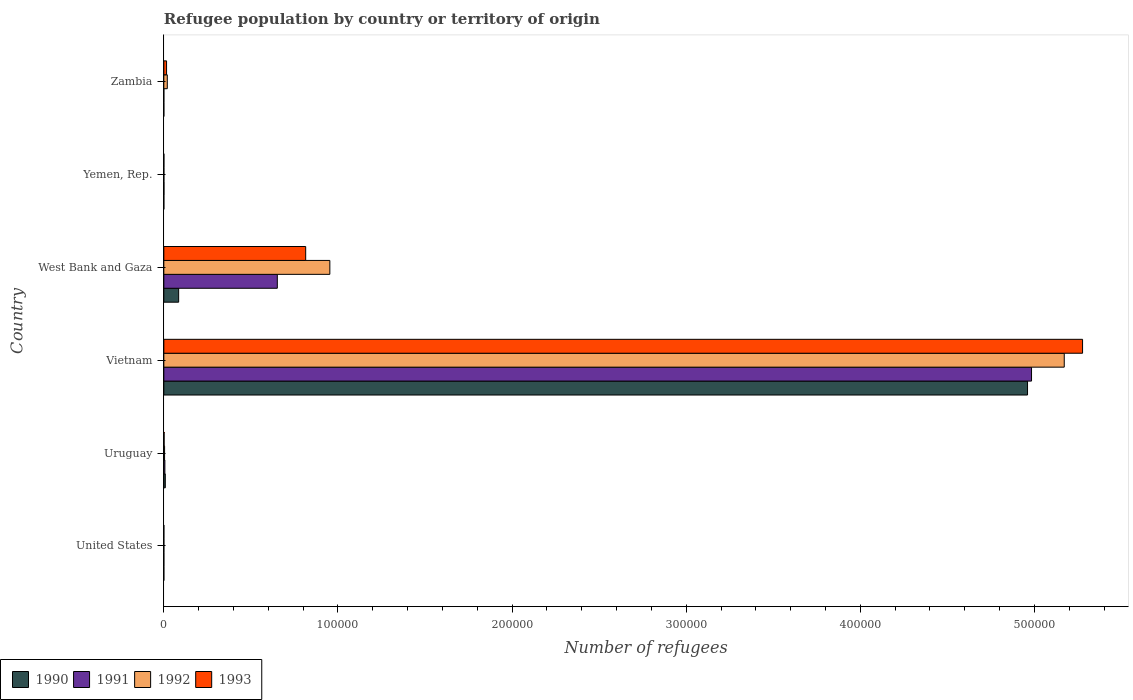How many different coloured bars are there?
Keep it short and to the point. 4. How many groups of bars are there?
Give a very brief answer. 6. Are the number of bars per tick equal to the number of legend labels?
Provide a succinct answer. Yes. Are the number of bars on each tick of the Y-axis equal?
Make the answer very short. Yes. How many bars are there on the 3rd tick from the bottom?
Make the answer very short. 4. What is the label of the 4th group of bars from the top?
Provide a short and direct response. Vietnam. What is the number of refugees in 1993 in Vietnam?
Your answer should be compact. 5.28e+05. Across all countries, what is the maximum number of refugees in 1991?
Ensure brevity in your answer.  4.98e+05. In which country was the number of refugees in 1991 maximum?
Keep it short and to the point. Vietnam. What is the total number of refugees in 1993 in the graph?
Keep it short and to the point. 6.11e+05. What is the difference between the number of refugees in 1991 in United States and that in Vietnam?
Provide a short and direct response. -4.98e+05. What is the difference between the number of refugees in 1991 in Yemen, Rep. and the number of refugees in 1992 in Zambia?
Your response must be concise. -1917. What is the average number of refugees in 1991 per country?
Ensure brevity in your answer.  9.40e+04. What is the difference between the number of refugees in 1991 and number of refugees in 1992 in Uruguay?
Keep it short and to the point. 172. In how many countries, is the number of refugees in 1993 greater than 500000 ?
Provide a succinct answer. 1. What is the ratio of the number of refugees in 1991 in United States to that in Uruguay?
Ensure brevity in your answer.  0.01. Is the difference between the number of refugees in 1991 in United States and Uruguay greater than the difference between the number of refugees in 1992 in United States and Uruguay?
Keep it short and to the point. No. What is the difference between the highest and the second highest number of refugees in 1990?
Your answer should be very brief. 4.88e+05. What is the difference between the highest and the lowest number of refugees in 1992?
Offer a terse response. 5.17e+05. In how many countries, is the number of refugees in 1991 greater than the average number of refugees in 1991 taken over all countries?
Give a very brief answer. 1. Is it the case that in every country, the sum of the number of refugees in 1992 and number of refugees in 1990 is greater than the sum of number of refugees in 1993 and number of refugees in 1991?
Offer a terse response. No. Is it the case that in every country, the sum of the number of refugees in 1992 and number of refugees in 1993 is greater than the number of refugees in 1991?
Offer a terse response. No. How many bars are there?
Offer a terse response. 24. Are the values on the major ticks of X-axis written in scientific E-notation?
Offer a very short reply. No. Does the graph contain any zero values?
Provide a succinct answer. No. Does the graph contain grids?
Provide a short and direct response. No. How are the legend labels stacked?
Your answer should be compact. Horizontal. What is the title of the graph?
Your answer should be compact. Refugee population by country or territory of origin. Does "2013" appear as one of the legend labels in the graph?
Ensure brevity in your answer.  No. What is the label or title of the X-axis?
Provide a succinct answer. Number of refugees. What is the label or title of the Y-axis?
Your response must be concise. Country. What is the Number of refugees of 1990 in United States?
Make the answer very short. 1. What is the Number of refugees in 1990 in Uruguay?
Offer a very short reply. 842. What is the Number of refugees of 1991 in Uruguay?
Your answer should be very brief. 601. What is the Number of refugees in 1992 in Uruguay?
Give a very brief answer. 429. What is the Number of refugees of 1993 in Uruguay?
Your answer should be very brief. 162. What is the Number of refugees of 1990 in Vietnam?
Your answer should be very brief. 4.96e+05. What is the Number of refugees of 1991 in Vietnam?
Offer a very short reply. 4.98e+05. What is the Number of refugees in 1992 in Vietnam?
Keep it short and to the point. 5.17e+05. What is the Number of refugees of 1993 in Vietnam?
Offer a very short reply. 5.28e+05. What is the Number of refugees in 1990 in West Bank and Gaza?
Your answer should be compact. 8521. What is the Number of refugees of 1991 in West Bank and Gaza?
Your response must be concise. 6.52e+04. What is the Number of refugees of 1992 in West Bank and Gaza?
Offer a terse response. 9.53e+04. What is the Number of refugees of 1993 in West Bank and Gaza?
Provide a succinct answer. 8.15e+04. What is the Number of refugees in 1990 in Yemen, Rep.?
Your response must be concise. 8. What is the Number of refugees in 1993 in Yemen, Rep.?
Give a very brief answer. 39. What is the Number of refugees in 1990 in Zambia?
Your response must be concise. 1. What is the Number of refugees of 1991 in Zambia?
Provide a short and direct response. 1. What is the Number of refugees in 1992 in Zambia?
Your answer should be very brief. 1990. What is the Number of refugees in 1993 in Zambia?
Keep it short and to the point. 1574. Across all countries, what is the maximum Number of refugees of 1990?
Offer a terse response. 4.96e+05. Across all countries, what is the maximum Number of refugees in 1991?
Give a very brief answer. 4.98e+05. Across all countries, what is the maximum Number of refugees in 1992?
Make the answer very short. 5.17e+05. Across all countries, what is the maximum Number of refugees of 1993?
Keep it short and to the point. 5.28e+05. Across all countries, what is the minimum Number of refugees of 1990?
Your answer should be very brief. 1. Across all countries, what is the minimum Number of refugees of 1991?
Keep it short and to the point. 1. Across all countries, what is the minimum Number of refugees in 1993?
Your answer should be very brief. 12. What is the total Number of refugees of 1990 in the graph?
Offer a terse response. 5.05e+05. What is the total Number of refugees in 1991 in the graph?
Provide a short and direct response. 5.64e+05. What is the total Number of refugees in 1992 in the graph?
Offer a terse response. 6.15e+05. What is the total Number of refugees in 1993 in the graph?
Make the answer very short. 6.11e+05. What is the difference between the Number of refugees in 1990 in United States and that in Uruguay?
Provide a succinct answer. -841. What is the difference between the Number of refugees in 1991 in United States and that in Uruguay?
Make the answer very short. -593. What is the difference between the Number of refugees in 1992 in United States and that in Uruguay?
Ensure brevity in your answer.  -419. What is the difference between the Number of refugees of 1993 in United States and that in Uruguay?
Make the answer very short. -150. What is the difference between the Number of refugees of 1990 in United States and that in Vietnam?
Make the answer very short. -4.96e+05. What is the difference between the Number of refugees of 1991 in United States and that in Vietnam?
Keep it short and to the point. -4.98e+05. What is the difference between the Number of refugees of 1992 in United States and that in Vietnam?
Offer a very short reply. -5.17e+05. What is the difference between the Number of refugees in 1993 in United States and that in Vietnam?
Your answer should be compact. -5.28e+05. What is the difference between the Number of refugees of 1990 in United States and that in West Bank and Gaza?
Make the answer very short. -8520. What is the difference between the Number of refugees in 1991 in United States and that in West Bank and Gaza?
Offer a terse response. -6.52e+04. What is the difference between the Number of refugees in 1992 in United States and that in West Bank and Gaza?
Offer a terse response. -9.53e+04. What is the difference between the Number of refugees in 1993 in United States and that in West Bank and Gaza?
Provide a succinct answer. -8.15e+04. What is the difference between the Number of refugees in 1990 in United States and that in Yemen, Rep.?
Ensure brevity in your answer.  -7. What is the difference between the Number of refugees of 1991 in United States and that in Yemen, Rep.?
Provide a succinct answer. -65. What is the difference between the Number of refugees in 1992 in United States and that in Yemen, Rep.?
Offer a very short reply. -21. What is the difference between the Number of refugees of 1990 in United States and that in Zambia?
Ensure brevity in your answer.  0. What is the difference between the Number of refugees in 1992 in United States and that in Zambia?
Your answer should be compact. -1980. What is the difference between the Number of refugees in 1993 in United States and that in Zambia?
Offer a very short reply. -1562. What is the difference between the Number of refugees in 1990 in Uruguay and that in Vietnam?
Provide a succinct answer. -4.95e+05. What is the difference between the Number of refugees of 1991 in Uruguay and that in Vietnam?
Keep it short and to the point. -4.98e+05. What is the difference between the Number of refugees of 1992 in Uruguay and that in Vietnam?
Your answer should be compact. -5.17e+05. What is the difference between the Number of refugees of 1993 in Uruguay and that in Vietnam?
Make the answer very short. -5.27e+05. What is the difference between the Number of refugees of 1990 in Uruguay and that in West Bank and Gaza?
Provide a short and direct response. -7679. What is the difference between the Number of refugees of 1991 in Uruguay and that in West Bank and Gaza?
Provide a short and direct response. -6.46e+04. What is the difference between the Number of refugees in 1992 in Uruguay and that in West Bank and Gaza?
Your response must be concise. -9.49e+04. What is the difference between the Number of refugees in 1993 in Uruguay and that in West Bank and Gaza?
Your answer should be very brief. -8.13e+04. What is the difference between the Number of refugees in 1990 in Uruguay and that in Yemen, Rep.?
Provide a succinct answer. 834. What is the difference between the Number of refugees of 1991 in Uruguay and that in Yemen, Rep.?
Make the answer very short. 528. What is the difference between the Number of refugees of 1992 in Uruguay and that in Yemen, Rep.?
Provide a succinct answer. 398. What is the difference between the Number of refugees of 1993 in Uruguay and that in Yemen, Rep.?
Give a very brief answer. 123. What is the difference between the Number of refugees of 1990 in Uruguay and that in Zambia?
Your answer should be very brief. 841. What is the difference between the Number of refugees in 1991 in Uruguay and that in Zambia?
Ensure brevity in your answer.  600. What is the difference between the Number of refugees of 1992 in Uruguay and that in Zambia?
Make the answer very short. -1561. What is the difference between the Number of refugees of 1993 in Uruguay and that in Zambia?
Your answer should be compact. -1412. What is the difference between the Number of refugees in 1990 in Vietnam and that in West Bank and Gaza?
Give a very brief answer. 4.88e+05. What is the difference between the Number of refugees in 1991 in Vietnam and that in West Bank and Gaza?
Provide a succinct answer. 4.33e+05. What is the difference between the Number of refugees in 1992 in Vietnam and that in West Bank and Gaza?
Give a very brief answer. 4.22e+05. What is the difference between the Number of refugees in 1993 in Vietnam and that in West Bank and Gaza?
Your answer should be very brief. 4.46e+05. What is the difference between the Number of refugees in 1990 in Vietnam and that in Yemen, Rep.?
Offer a terse response. 4.96e+05. What is the difference between the Number of refugees in 1991 in Vietnam and that in Yemen, Rep.?
Ensure brevity in your answer.  4.98e+05. What is the difference between the Number of refugees in 1992 in Vietnam and that in Yemen, Rep.?
Give a very brief answer. 5.17e+05. What is the difference between the Number of refugees in 1993 in Vietnam and that in Yemen, Rep.?
Your answer should be compact. 5.28e+05. What is the difference between the Number of refugees of 1990 in Vietnam and that in Zambia?
Your answer should be compact. 4.96e+05. What is the difference between the Number of refugees in 1991 in Vietnam and that in Zambia?
Offer a very short reply. 4.98e+05. What is the difference between the Number of refugees of 1992 in Vietnam and that in Zambia?
Your answer should be very brief. 5.15e+05. What is the difference between the Number of refugees of 1993 in Vietnam and that in Zambia?
Ensure brevity in your answer.  5.26e+05. What is the difference between the Number of refugees of 1990 in West Bank and Gaza and that in Yemen, Rep.?
Offer a terse response. 8513. What is the difference between the Number of refugees in 1991 in West Bank and Gaza and that in Yemen, Rep.?
Ensure brevity in your answer.  6.51e+04. What is the difference between the Number of refugees in 1992 in West Bank and Gaza and that in Yemen, Rep.?
Provide a succinct answer. 9.53e+04. What is the difference between the Number of refugees of 1993 in West Bank and Gaza and that in Yemen, Rep.?
Provide a short and direct response. 8.14e+04. What is the difference between the Number of refugees of 1990 in West Bank and Gaza and that in Zambia?
Your answer should be compact. 8520. What is the difference between the Number of refugees of 1991 in West Bank and Gaza and that in Zambia?
Provide a short and direct response. 6.52e+04. What is the difference between the Number of refugees in 1992 in West Bank and Gaza and that in Zambia?
Keep it short and to the point. 9.34e+04. What is the difference between the Number of refugees of 1993 in West Bank and Gaza and that in Zambia?
Your answer should be very brief. 7.99e+04. What is the difference between the Number of refugees in 1991 in Yemen, Rep. and that in Zambia?
Give a very brief answer. 72. What is the difference between the Number of refugees in 1992 in Yemen, Rep. and that in Zambia?
Offer a very short reply. -1959. What is the difference between the Number of refugees of 1993 in Yemen, Rep. and that in Zambia?
Your answer should be compact. -1535. What is the difference between the Number of refugees of 1990 in United States and the Number of refugees of 1991 in Uruguay?
Give a very brief answer. -600. What is the difference between the Number of refugees of 1990 in United States and the Number of refugees of 1992 in Uruguay?
Provide a succinct answer. -428. What is the difference between the Number of refugees of 1990 in United States and the Number of refugees of 1993 in Uruguay?
Offer a very short reply. -161. What is the difference between the Number of refugees in 1991 in United States and the Number of refugees in 1992 in Uruguay?
Offer a very short reply. -421. What is the difference between the Number of refugees of 1991 in United States and the Number of refugees of 1993 in Uruguay?
Your answer should be compact. -154. What is the difference between the Number of refugees in 1992 in United States and the Number of refugees in 1993 in Uruguay?
Keep it short and to the point. -152. What is the difference between the Number of refugees in 1990 in United States and the Number of refugees in 1991 in Vietnam?
Provide a short and direct response. -4.98e+05. What is the difference between the Number of refugees of 1990 in United States and the Number of refugees of 1992 in Vietnam?
Your answer should be compact. -5.17e+05. What is the difference between the Number of refugees of 1990 in United States and the Number of refugees of 1993 in Vietnam?
Your answer should be very brief. -5.28e+05. What is the difference between the Number of refugees of 1991 in United States and the Number of refugees of 1992 in Vietnam?
Your answer should be compact. -5.17e+05. What is the difference between the Number of refugees of 1991 in United States and the Number of refugees of 1993 in Vietnam?
Offer a terse response. -5.28e+05. What is the difference between the Number of refugees of 1992 in United States and the Number of refugees of 1993 in Vietnam?
Provide a short and direct response. -5.28e+05. What is the difference between the Number of refugees in 1990 in United States and the Number of refugees in 1991 in West Bank and Gaza?
Provide a short and direct response. -6.52e+04. What is the difference between the Number of refugees in 1990 in United States and the Number of refugees in 1992 in West Bank and Gaza?
Ensure brevity in your answer.  -9.53e+04. What is the difference between the Number of refugees of 1990 in United States and the Number of refugees of 1993 in West Bank and Gaza?
Keep it short and to the point. -8.15e+04. What is the difference between the Number of refugees in 1991 in United States and the Number of refugees in 1992 in West Bank and Gaza?
Your answer should be very brief. -9.53e+04. What is the difference between the Number of refugees of 1991 in United States and the Number of refugees of 1993 in West Bank and Gaza?
Offer a terse response. -8.15e+04. What is the difference between the Number of refugees of 1992 in United States and the Number of refugees of 1993 in West Bank and Gaza?
Provide a short and direct response. -8.15e+04. What is the difference between the Number of refugees of 1990 in United States and the Number of refugees of 1991 in Yemen, Rep.?
Provide a succinct answer. -72. What is the difference between the Number of refugees in 1990 in United States and the Number of refugees in 1993 in Yemen, Rep.?
Your answer should be very brief. -38. What is the difference between the Number of refugees in 1991 in United States and the Number of refugees in 1993 in Yemen, Rep.?
Provide a succinct answer. -31. What is the difference between the Number of refugees of 1992 in United States and the Number of refugees of 1993 in Yemen, Rep.?
Offer a terse response. -29. What is the difference between the Number of refugees in 1990 in United States and the Number of refugees in 1992 in Zambia?
Your answer should be very brief. -1989. What is the difference between the Number of refugees in 1990 in United States and the Number of refugees in 1993 in Zambia?
Your answer should be very brief. -1573. What is the difference between the Number of refugees of 1991 in United States and the Number of refugees of 1992 in Zambia?
Provide a short and direct response. -1982. What is the difference between the Number of refugees of 1991 in United States and the Number of refugees of 1993 in Zambia?
Offer a terse response. -1566. What is the difference between the Number of refugees in 1992 in United States and the Number of refugees in 1993 in Zambia?
Your answer should be compact. -1564. What is the difference between the Number of refugees in 1990 in Uruguay and the Number of refugees in 1991 in Vietnam?
Offer a terse response. -4.97e+05. What is the difference between the Number of refugees of 1990 in Uruguay and the Number of refugees of 1992 in Vietnam?
Offer a very short reply. -5.16e+05. What is the difference between the Number of refugees of 1990 in Uruguay and the Number of refugees of 1993 in Vietnam?
Your answer should be very brief. -5.27e+05. What is the difference between the Number of refugees in 1991 in Uruguay and the Number of refugees in 1992 in Vietnam?
Make the answer very short. -5.17e+05. What is the difference between the Number of refugees in 1991 in Uruguay and the Number of refugees in 1993 in Vietnam?
Give a very brief answer. -5.27e+05. What is the difference between the Number of refugees of 1992 in Uruguay and the Number of refugees of 1993 in Vietnam?
Offer a very short reply. -5.27e+05. What is the difference between the Number of refugees in 1990 in Uruguay and the Number of refugees in 1991 in West Bank and Gaza?
Provide a short and direct response. -6.43e+04. What is the difference between the Number of refugees in 1990 in Uruguay and the Number of refugees in 1992 in West Bank and Gaza?
Keep it short and to the point. -9.45e+04. What is the difference between the Number of refugees in 1990 in Uruguay and the Number of refugees in 1993 in West Bank and Gaza?
Keep it short and to the point. -8.06e+04. What is the difference between the Number of refugees of 1991 in Uruguay and the Number of refugees of 1992 in West Bank and Gaza?
Your answer should be compact. -9.47e+04. What is the difference between the Number of refugees in 1991 in Uruguay and the Number of refugees in 1993 in West Bank and Gaza?
Provide a succinct answer. -8.09e+04. What is the difference between the Number of refugees in 1992 in Uruguay and the Number of refugees in 1993 in West Bank and Gaza?
Provide a succinct answer. -8.10e+04. What is the difference between the Number of refugees of 1990 in Uruguay and the Number of refugees of 1991 in Yemen, Rep.?
Keep it short and to the point. 769. What is the difference between the Number of refugees in 1990 in Uruguay and the Number of refugees in 1992 in Yemen, Rep.?
Provide a short and direct response. 811. What is the difference between the Number of refugees of 1990 in Uruguay and the Number of refugees of 1993 in Yemen, Rep.?
Ensure brevity in your answer.  803. What is the difference between the Number of refugees of 1991 in Uruguay and the Number of refugees of 1992 in Yemen, Rep.?
Provide a short and direct response. 570. What is the difference between the Number of refugees of 1991 in Uruguay and the Number of refugees of 1993 in Yemen, Rep.?
Ensure brevity in your answer.  562. What is the difference between the Number of refugees in 1992 in Uruguay and the Number of refugees in 1993 in Yemen, Rep.?
Provide a succinct answer. 390. What is the difference between the Number of refugees of 1990 in Uruguay and the Number of refugees of 1991 in Zambia?
Make the answer very short. 841. What is the difference between the Number of refugees of 1990 in Uruguay and the Number of refugees of 1992 in Zambia?
Give a very brief answer. -1148. What is the difference between the Number of refugees of 1990 in Uruguay and the Number of refugees of 1993 in Zambia?
Ensure brevity in your answer.  -732. What is the difference between the Number of refugees of 1991 in Uruguay and the Number of refugees of 1992 in Zambia?
Your answer should be very brief. -1389. What is the difference between the Number of refugees of 1991 in Uruguay and the Number of refugees of 1993 in Zambia?
Make the answer very short. -973. What is the difference between the Number of refugees of 1992 in Uruguay and the Number of refugees of 1993 in Zambia?
Keep it short and to the point. -1145. What is the difference between the Number of refugees of 1990 in Vietnam and the Number of refugees of 1991 in West Bank and Gaza?
Provide a short and direct response. 4.31e+05. What is the difference between the Number of refugees in 1990 in Vietnam and the Number of refugees in 1992 in West Bank and Gaza?
Your answer should be very brief. 4.01e+05. What is the difference between the Number of refugees in 1990 in Vietnam and the Number of refugees in 1993 in West Bank and Gaza?
Your answer should be compact. 4.15e+05. What is the difference between the Number of refugees of 1991 in Vietnam and the Number of refugees of 1992 in West Bank and Gaza?
Make the answer very short. 4.03e+05. What is the difference between the Number of refugees of 1991 in Vietnam and the Number of refugees of 1993 in West Bank and Gaza?
Provide a succinct answer. 4.17e+05. What is the difference between the Number of refugees in 1992 in Vietnam and the Number of refugees in 1993 in West Bank and Gaza?
Provide a succinct answer. 4.36e+05. What is the difference between the Number of refugees of 1990 in Vietnam and the Number of refugees of 1991 in Yemen, Rep.?
Give a very brief answer. 4.96e+05. What is the difference between the Number of refugees of 1990 in Vietnam and the Number of refugees of 1992 in Yemen, Rep.?
Ensure brevity in your answer.  4.96e+05. What is the difference between the Number of refugees in 1990 in Vietnam and the Number of refugees in 1993 in Yemen, Rep.?
Offer a very short reply. 4.96e+05. What is the difference between the Number of refugees in 1991 in Vietnam and the Number of refugees in 1992 in Yemen, Rep.?
Offer a terse response. 4.98e+05. What is the difference between the Number of refugees in 1991 in Vietnam and the Number of refugees in 1993 in Yemen, Rep.?
Provide a short and direct response. 4.98e+05. What is the difference between the Number of refugees of 1992 in Vietnam and the Number of refugees of 1993 in Yemen, Rep.?
Provide a short and direct response. 5.17e+05. What is the difference between the Number of refugees of 1990 in Vietnam and the Number of refugees of 1991 in Zambia?
Keep it short and to the point. 4.96e+05. What is the difference between the Number of refugees in 1990 in Vietnam and the Number of refugees in 1992 in Zambia?
Your answer should be compact. 4.94e+05. What is the difference between the Number of refugees in 1990 in Vietnam and the Number of refugees in 1993 in Zambia?
Ensure brevity in your answer.  4.94e+05. What is the difference between the Number of refugees of 1991 in Vietnam and the Number of refugees of 1992 in Zambia?
Offer a very short reply. 4.96e+05. What is the difference between the Number of refugees of 1991 in Vietnam and the Number of refugees of 1993 in Zambia?
Your response must be concise. 4.97e+05. What is the difference between the Number of refugees of 1992 in Vietnam and the Number of refugees of 1993 in Zambia?
Your answer should be very brief. 5.16e+05. What is the difference between the Number of refugees in 1990 in West Bank and Gaza and the Number of refugees in 1991 in Yemen, Rep.?
Keep it short and to the point. 8448. What is the difference between the Number of refugees in 1990 in West Bank and Gaza and the Number of refugees in 1992 in Yemen, Rep.?
Offer a very short reply. 8490. What is the difference between the Number of refugees in 1990 in West Bank and Gaza and the Number of refugees in 1993 in Yemen, Rep.?
Provide a succinct answer. 8482. What is the difference between the Number of refugees of 1991 in West Bank and Gaza and the Number of refugees of 1992 in Yemen, Rep.?
Offer a terse response. 6.51e+04. What is the difference between the Number of refugees of 1991 in West Bank and Gaza and the Number of refugees of 1993 in Yemen, Rep.?
Offer a terse response. 6.51e+04. What is the difference between the Number of refugees of 1992 in West Bank and Gaza and the Number of refugees of 1993 in Yemen, Rep.?
Give a very brief answer. 9.53e+04. What is the difference between the Number of refugees in 1990 in West Bank and Gaza and the Number of refugees in 1991 in Zambia?
Provide a succinct answer. 8520. What is the difference between the Number of refugees of 1990 in West Bank and Gaza and the Number of refugees of 1992 in Zambia?
Make the answer very short. 6531. What is the difference between the Number of refugees in 1990 in West Bank and Gaza and the Number of refugees in 1993 in Zambia?
Your answer should be compact. 6947. What is the difference between the Number of refugees of 1991 in West Bank and Gaza and the Number of refugees of 1992 in Zambia?
Offer a terse response. 6.32e+04. What is the difference between the Number of refugees in 1991 in West Bank and Gaza and the Number of refugees in 1993 in Zambia?
Provide a succinct answer. 6.36e+04. What is the difference between the Number of refugees in 1992 in West Bank and Gaza and the Number of refugees in 1993 in Zambia?
Keep it short and to the point. 9.38e+04. What is the difference between the Number of refugees of 1990 in Yemen, Rep. and the Number of refugees of 1992 in Zambia?
Ensure brevity in your answer.  -1982. What is the difference between the Number of refugees of 1990 in Yemen, Rep. and the Number of refugees of 1993 in Zambia?
Your answer should be compact. -1566. What is the difference between the Number of refugees of 1991 in Yemen, Rep. and the Number of refugees of 1992 in Zambia?
Provide a short and direct response. -1917. What is the difference between the Number of refugees in 1991 in Yemen, Rep. and the Number of refugees in 1993 in Zambia?
Your answer should be compact. -1501. What is the difference between the Number of refugees in 1992 in Yemen, Rep. and the Number of refugees in 1993 in Zambia?
Make the answer very short. -1543. What is the average Number of refugees of 1990 per country?
Your response must be concise. 8.42e+04. What is the average Number of refugees of 1991 per country?
Give a very brief answer. 9.40e+04. What is the average Number of refugees of 1992 per country?
Make the answer very short. 1.02e+05. What is the average Number of refugees of 1993 per country?
Offer a terse response. 1.02e+05. What is the difference between the Number of refugees of 1990 and Number of refugees of 1991 in United States?
Provide a succinct answer. -7. What is the difference between the Number of refugees in 1990 and Number of refugees in 1992 in United States?
Your answer should be very brief. -9. What is the difference between the Number of refugees of 1990 and Number of refugees of 1993 in United States?
Provide a short and direct response. -11. What is the difference between the Number of refugees in 1991 and Number of refugees in 1992 in United States?
Make the answer very short. -2. What is the difference between the Number of refugees in 1991 and Number of refugees in 1993 in United States?
Offer a terse response. -4. What is the difference between the Number of refugees in 1992 and Number of refugees in 1993 in United States?
Make the answer very short. -2. What is the difference between the Number of refugees in 1990 and Number of refugees in 1991 in Uruguay?
Your answer should be very brief. 241. What is the difference between the Number of refugees of 1990 and Number of refugees of 1992 in Uruguay?
Ensure brevity in your answer.  413. What is the difference between the Number of refugees in 1990 and Number of refugees in 1993 in Uruguay?
Your answer should be compact. 680. What is the difference between the Number of refugees of 1991 and Number of refugees of 1992 in Uruguay?
Provide a succinct answer. 172. What is the difference between the Number of refugees of 1991 and Number of refugees of 1993 in Uruguay?
Offer a very short reply. 439. What is the difference between the Number of refugees of 1992 and Number of refugees of 1993 in Uruguay?
Provide a short and direct response. 267. What is the difference between the Number of refugees of 1990 and Number of refugees of 1991 in Vietnam?
Keep it short and to the point. -2294. What is the difference between the Number of refugees of 1990 and Number of refugees of 1992 in Vietnam?
Give a very brief answer. -2.11e+04. What is the difference between the Number of refugees in 1990 and Number of refugees in 1993 in Vietnam?
Your response must be concise. -3.16e+04. What is the difference between the Number of refugees in 1991 and Number of refugees in 1992 in Vietnam?
Ensure brevity in your answer.  -1.88e+04. What is the difference between the Number of refugees in 1991 and Number of refugees in 1993 in Vietnam?
Provide a short and direct response. -2.93e+04. What is the difference between the Number of refugees of 1992 and Number of refugees of 1993 in Vietnam?
Your answer should be compact. -1.05e+04. What is the difference between the Number of refugees of 1990 and Number of refugees of 1991 in West Bank and Gaza?
Ensure brevity in your answer.  -5.67e+04. What is the difference between the Number of refugees in 1990 and Number of refugees in 1992 in West Bank and Gaza?
Offer a very short reply. -8.68e+04. What is the difference between the Number of refugees of 1990 and Number of refugees of 1993 in West Bank and Gaza?
Your answer should be very brief. -7.30e+04. What is the difference between the Number of refugees in 1991 and Number of refugees in 1992 in West Bank and Gaza?
Keep it short and to the point. -3.02e+04. What is the difference between the Number of refugees in 1991 and Number of refugees in 1993 in West Bank and Gaza?
Make the answer very short. -1.63e+04. What is the difference between the Number of refugees of 1992 and Number of refugees of 1993 in West Bank and Gaza?
Your answer should be very brief. 1.39e+04. What is the difference between the Number of refugees in 1990 and Number of refugees in 1991 in Yemen, Rep.?
Offer a very short reply. -65. What is the difference between the Number of refugees in 1990 and Number of refugees in 1992 in Yemen, Rep.?
Your response must be concise. -23. What is the difference between the Number of refugees of 1990 and Number of refugees of 1993 in Yemen, Rep.?
Give a very brief answer. -31. What is the difference between the Number of refugees in 1991 and Number of refugees in 1993 in Yemen, Rep.?
Give a very brief answer. 34. What is the difference between the Number of refugees of 1990 and Number of refugees of 1992 in Zambia?
Give a very brief answer. -1989. What is the difference between the Number of refugees of 1990 and Number of refugees of 1993 in Zambia?
Keep it short and to the point. -1573. What is the difference between the Number of refugees in 1991 and Number of refugees in 1992 in Zambia?
Your answer should be very brief. -1989. What is the difference between the Number of refugees of 1991 and Number of refugees of 1993 in Zambia?
Your answer should be compact. -1573. What is the difference between the Number of refugees of 1992 and Number of refugees of 1993 in Zambia?
Give a very brief answer. 416. What is the ratio of the Number of refugees of 1990 in United States to that in Uruguay?
Provide a succinct answer. 0. What is the ratio of the Number of refugees of 1991 in United States to that in Uruguay?
Ensure brevity in your answer.  0.01. What is the ratio of the Number of refugees of 1992 in United States to that in Uruguay?
Make the answer very short. 0.02. What is the ratio of the Number of refugees in 1993 in United States to that in Uruguay?
Give a very brief answer. 0.07. What is the ratio of the Number of refugees in 1992 in United States to that in Vietnam?
Your response must be concise. 0. What is the ratio of the Number of refugees in 1993 in United States to that in Vietnam?
Give a very brief answer. 0. What is the ratio of the Number of refugees in 1991 in United States to that in West Bank and Gaza?
Give a very brief answer. 0. What is the ratio of the Number of refugees of 1992 in United States to that in West Bank and Gaza?
Ensure brevity in your answer.  0. What is the ratio of the Number of refugees of 1991 in United States to that in Yemen, Rep.?
Keep it short and to the point. 0.11. What is the ratio of the Number of refugees of 1992 in United States to that in Yemen, Rep.?
Offer a very short reply. 0.32. What is the ratio of the Number of refugees in 1993 in United States to that in Yemen, Rep.?
Provide a short and direct response. 0.31. What is the ratio of the Number of refugees in 1991 in United States to that in Zambia?
Your response must be concise. 8. What is the ratio of the Number of refugees in 1992 in United States to that in Zambia?
Offer a terse response. 0.01. What is the ratio of the Number of refugees of 1993 in United States to that in Zambia?
Your answer should be compact. 0.01. What is the ratio of the Number of refugees of 1990 in Uruguay to that in Vietnam?
Make the answer very short. 0. What is the ratio of the Number of refugees of 1991 in Uruguay to that in Vietnam?
Make the answer very short. 0. What is the ratio of the Number of refugees in 1992 in Uruguay to that in Vietnam?
Provide a short and direct response. 0. What is the ratio of the Number of refugees of 1993 in Uruguay to that in Vietnam?
Provide a short and direct response. 0. What is the ratio of the Number of refugees of 1990 in Uruguay to that in West Bank and Gaza?
Your answer should be compact. 0.1. What is the ratio of the Number of refugees in 1991 in Uruguay to that in West Bank and Gaza?
Your answer should be very brief. 0.01. What is the ratio of the Number of refugees in 1992 in Uruguay to that in West Bank and Gaza?
Keep it short and to the point. 0. What is the ratio of the Number of refugees in 1993 in Uruguay to that in West Bank and Gaza?
Offer a very short reply. 0. What is the ratio of the Number of refugees of 1990 in Uruguay to that in Yemen, Rep.?
Your response must be concise. 105.25. What is the ratio of the Number of refugees in 1991 in Uruguay to that in Yemen, Rep.?
Make the answer very short. 8.23. What is the ratio of the Number of refugees of 1992 in Uruguay to that in Yemen, Rep.?
Ensure brevity in your answer.  13.84. What is the ratio of the Number of refugees of 1993 in Uruguay to that in Yemen, Rep.?
Your answer should be compact. 4.15. What is the ratio of the Number of refugees in 1990 in Uruguay to that in Zambia?
Your answer should be very brief. 842. What is the ratio of the Number of refugees of 1991 in Uruguay to that in Zambia?
Offer a very short reply. 601. What is the ratio of the Number of refugees of 1992 in Uruguay to that in Zambia?
Provide a short and direct response. 0.22. What is the ratio of the Number of refugees in 1993 in Uruguay to that in Zambia?
Keep it short and to the point. 0.1. What is the ratio of the Number of refugees of 1990 in Vietnam to that in West Bank and Gaza?
Offer a terse response. 58.21. What is the ratio of the Number of refugees in 1991 in Vietnam to that in West Bank and Gaza?
Your response must be concise. 7.65. What is the ratio of the Number of refugees in 1992 in Vietnam to that in West Bank and Gaza?
Ensure brevity in your answer.  5.42. What is the ratio of the Number of refugees of 1993 in Vietnam to that in West Bank and Gaza?
Your answer should be compact. 6.48. What is the ratio of the Number of refugees in 1990 in Vietnam to that in Yemen, Rep.?
Keep it short and to the point. 6.20e+04. What is the ratio of the Number of refugees of 1991 in Vietnam to that in Yemen, Rep.?
Your answer should be very brief. 6826.34. What is the ratio of the Number of refugees of 1992 in Vietnam to that in Yemen, Rep.?
Make the answer very short. 1.67e+04. What is the ratio of the Number of refugees of 1993 in Vietnam to that in Yemen, Rep.?
Provide a succinct answer. 1.35e+04. What is the ratio of the Number of refugees of 1990 in Vietnam to that in Zambia?
Provide a succinct answer. 4.96e+05. What is the ratio of the Number of refugees of 1991 in Vietnam to that in Zambia?
Make the answer very short. 4.98e+05. What is the ratio of the Number of refugees of 1992 in Vietnam to that in Zambia?
Your response must be concise. 259.85. What is the ratio of the Number of refugees of 1993 in Vietnam to that in Zambia?
Make the answer very short. 335.21. What is the ratio of the Number of refugees of 1990 in West Bank and Gaza to that in Yemen, Rep.?
Give a very brief answer. 1065.12. What is the ratio of the Number of refugees in 1991 in West Bank and Gaza to that in Yemen, Rep.?
Your response must be concise. 892.84. What is the ratio of the Number of refugees in 1992 in West Bank and Gaza to that in Yemen, Rep.?
Offer a very short reply. 3075.58. What is the ratio of the Number of refugees in 1993 in West Bank and Gaza to that in Yemen, Rep.?
Provide a succinct answer. 2089.08. What is the ratio of the Number of refugees of 1990 in West Bank and Gaza to that in Zambia?
Give a very brief answer. 8521. What is the ratio of the Number of refugees of 1991 in West Bank and Gaza to that in Zambia?
Ensure brevity in your answer.  6.52e+04. What is the ratio of the Number of refugees of 1992 in West Bank and Gaza to that in Zambia?
Your answer should be compact. 47.91. What is the ratio of the Number of refugees in 1993 in West Bank and Gaza to that in Zambia?
Provide a succinct answer. 51.76. What is the ratio of the Number of refugees in 1990 in Yemen, Rep. to that in Zambia?
Your answer should be very brief. 8. What is the ratio of the Number of refugees of 1992 in Yemen, Rep. to that in Zambia?
Offer a terse response. 0.02. What is the ratio of the Number of refugees in 1993 in Yemen, Rep. to that in Zambia?
Provide a short and direct response. 0.02. What is the difference between the highest and the second highest Number of refugees of 1990?
Your answer should be very brief. 4.88e+05. What is the difference between the highest and the second highest Number of refugees in 1991?
Ensure brevity in your answer.  4.33e+05. What is the difference between the highest and the second highest Number of refugees of 1992?
Keep it short and to the point. 4.22e+05. What is the difference between the highest and the second highest Number of refugees in 1993?
Make the answer very short. 4.46e+05. What is the difference between the highest and the lowest Number of refugees of 1990?
Your answer should be compact. 4.96e+05. What is the difference between the highest and the lowest Number of refugees in 1991?
Your answer should be very brief. 4.98e+05. What is the difference between the highest and the lowest Number of refugees of 1992?
Offer a very short reply. 5.17e+05. What is the difference between the highest and the lowest Number of refugees in 1993?
Offer a terse response. 5.28e+05. 